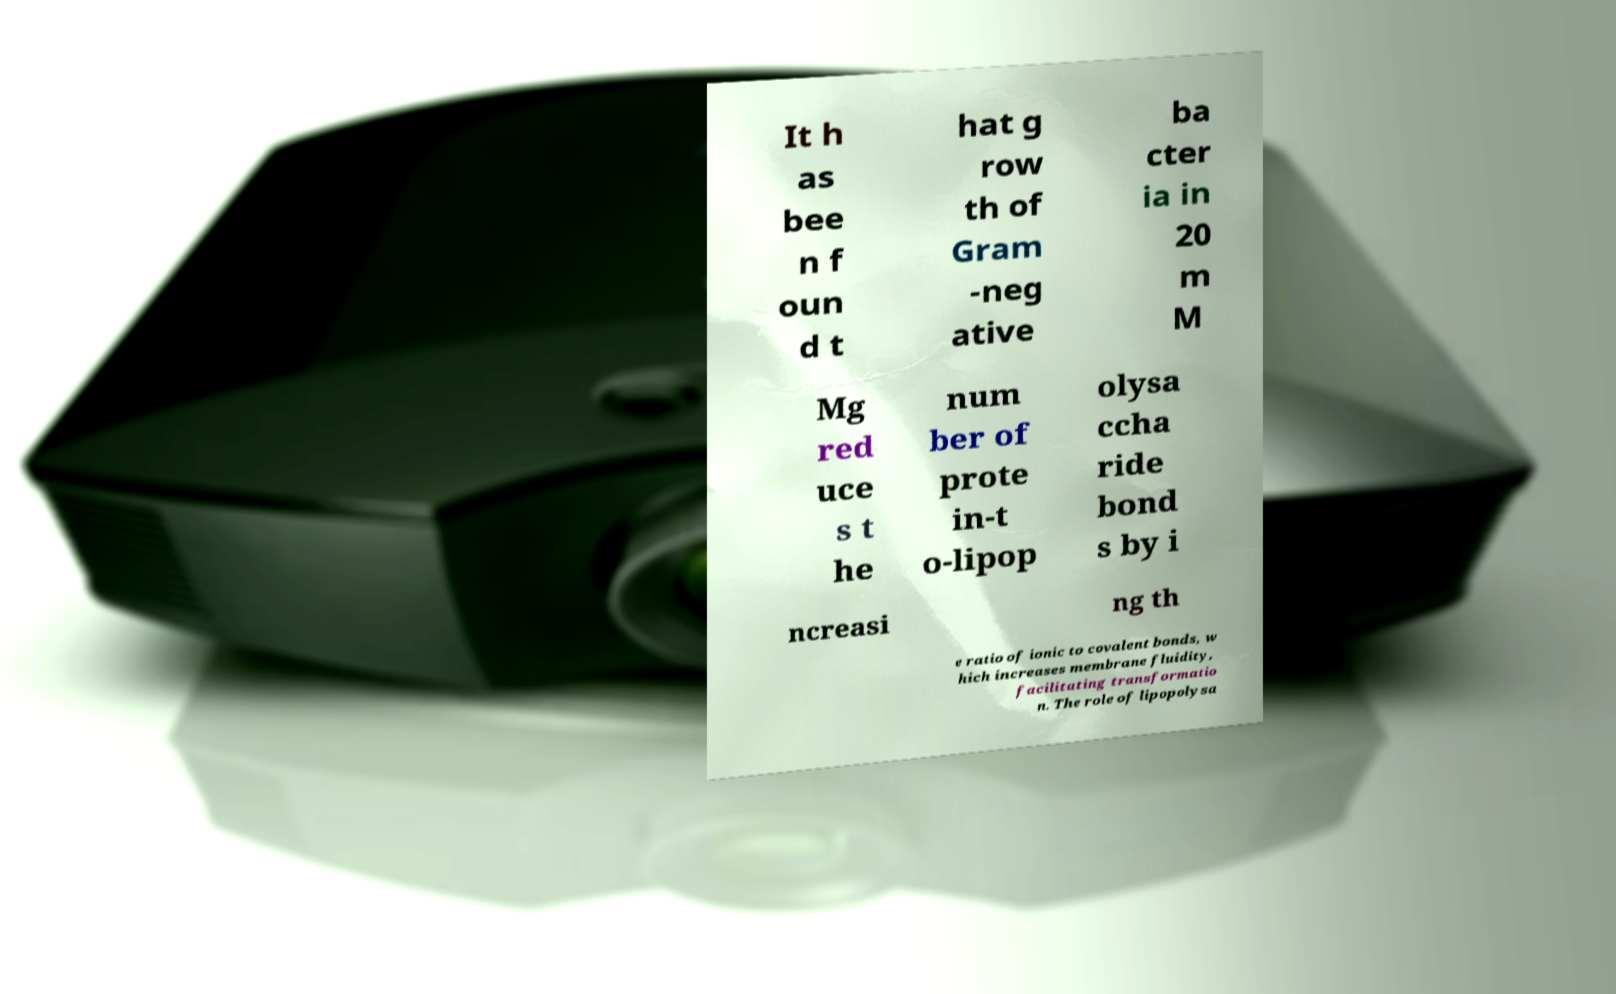Could you assist in decoding the text presented in this image and type it out clearly? It h as bee n f oun d t hat g row th of Gram -neg ative ba cter ia in 20 m M Mg red uce s t he num ber of prote in-t o-lipop olysa ccha ride bond s by i ncreasi ng th e ratio of ionic to covalent bonds, w hich increases membrane fluidity, facilitating transformatio n. The role of lipopolysa 